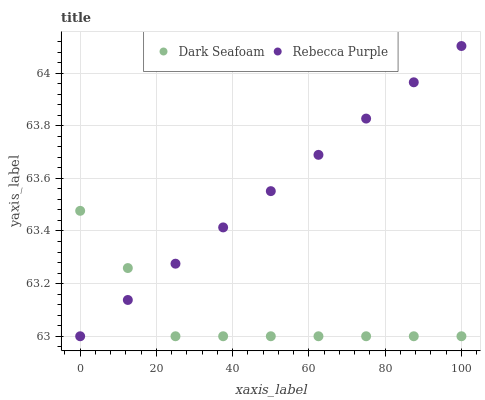Does Dark Seafoam have the minimum area under the curve?
Answer yes or no. Yes. Does Rebecca Purple have the maximum area under the curve?
Answer yes or no. Yes. Does Rebecca Purple have the minimum area under the curve?
Answer yes or no. No. Is Rebecca Purple the smoothest?
Answer yes or no. Yes. Is Dark Seafoam the roughest?
Answer yes or no. Yes. Is Rebecca Purple the roughest?
Answer yes or no. No. Does Dark Seafoam have the lowest value?
Answer yes or no. Yes. Does Rebecca Purple have the highest value?
Answer yes or no. Yes. Does Dark Seafoam intersect Rebecca Purple?
Answer yes or no. Yes. Is Dark Seafoam less than Rebecca Purple?
Answer yes or no. No. Is Dark Seafoam greater than Rebecca Purple?
Answer yes or no. No. 